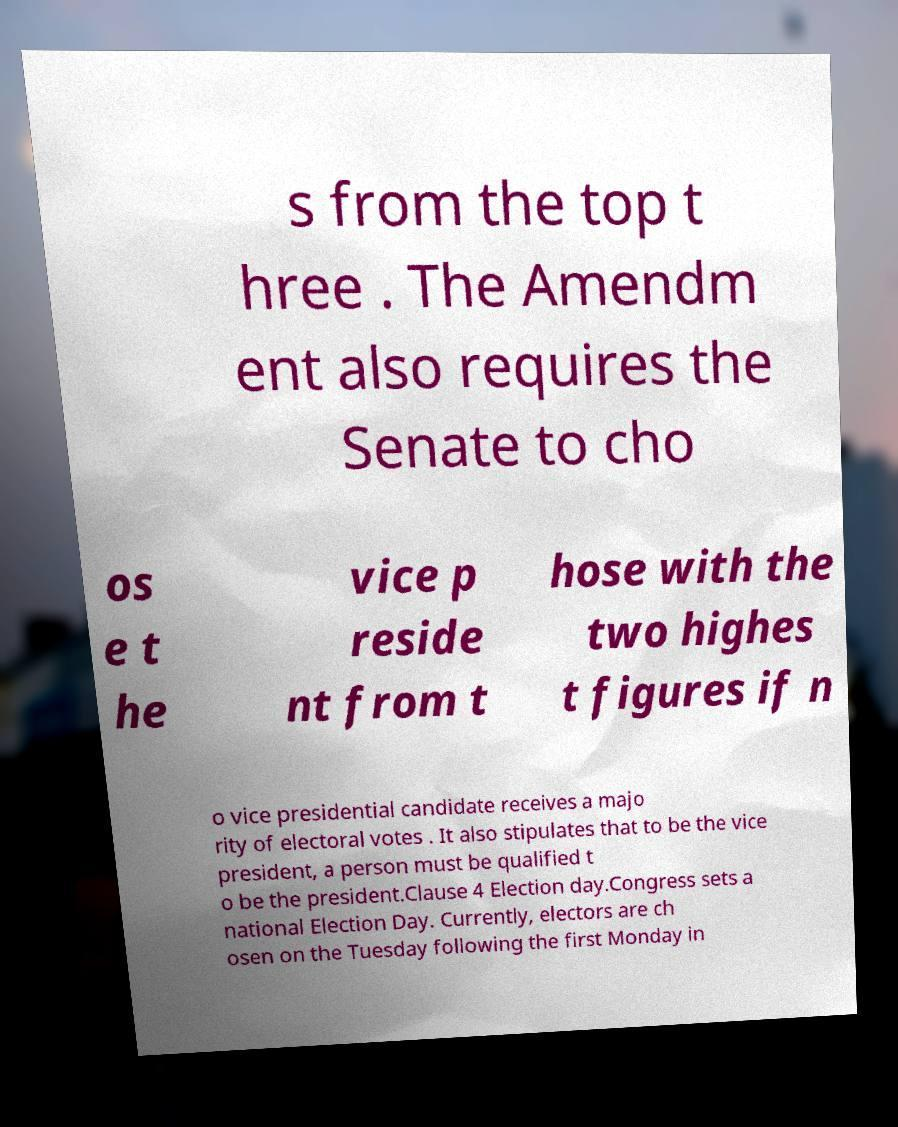Could you extract and type out the text from this image? s from the top t hree . The Amendm ent also requires the Senate to cho os e t he vice p reside nt from t hose with the two highes t figures if n o vice presidential candidate receives a majo rity of electoral votes . It also stipulates that to be the vice president, a person must be qualified t o be the president.Clause 4 Election day.Congress sets a national Election Day. Currently, electors are ch osen on the Tuesday following the first Monday in 